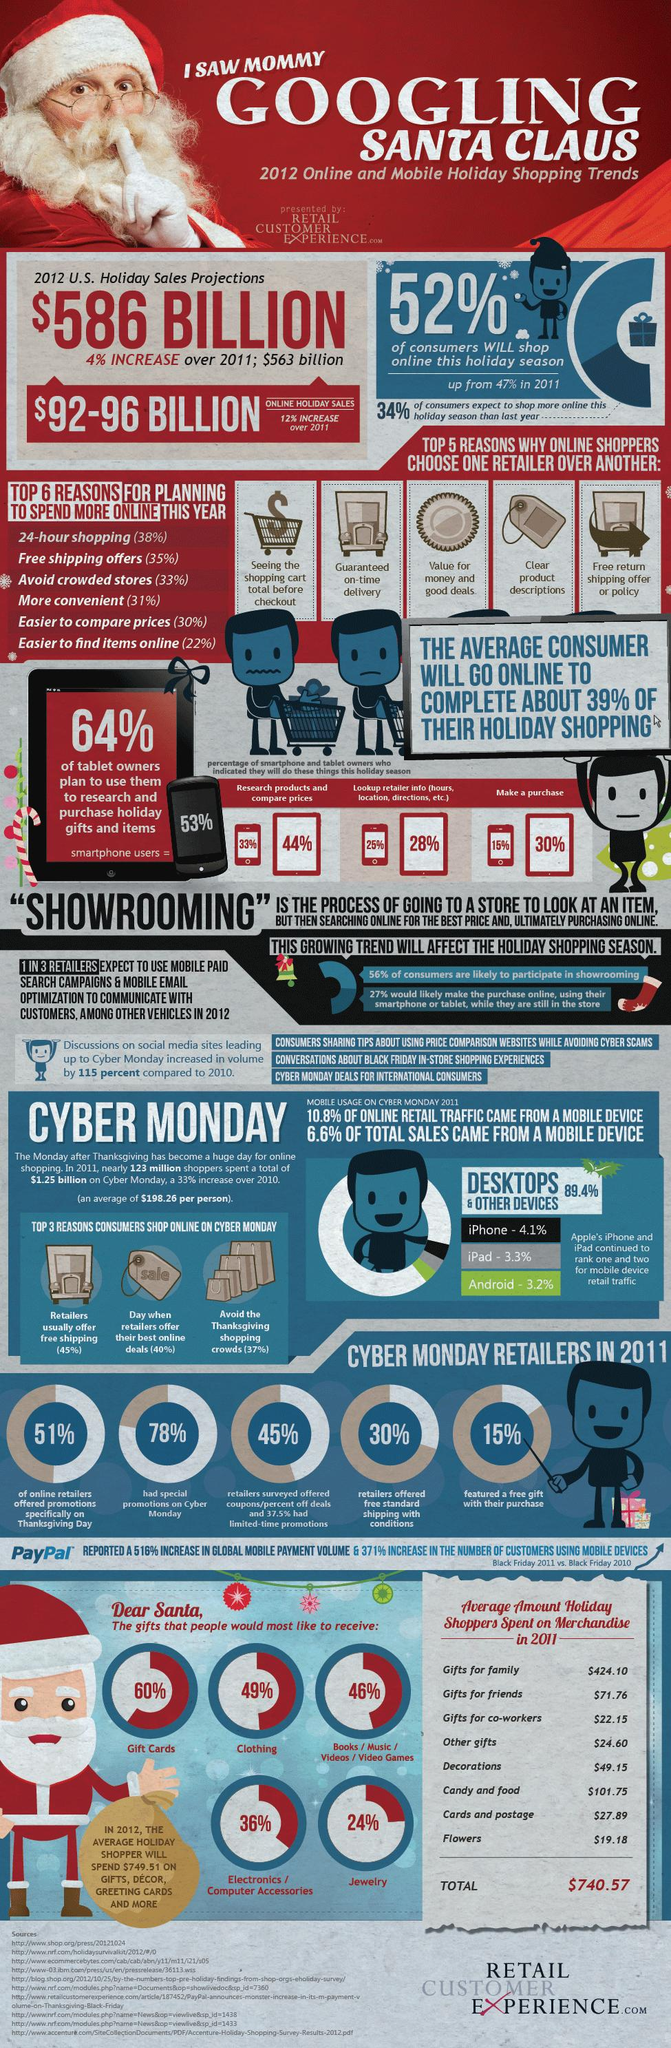Highlight a few significant elements in this photo. In the 2012 holiday season, it is projected that approximately 48% of people will not shop online. According to a recent survey, 44% of people use tablets to research products and compare prices. According to a recent survey, 25% of smartphone users check retailer information on their devices. The third most popular mobile device for retail traffic is Android. According to data, 30% of retailers offered free shipping on Cyber Monday. 